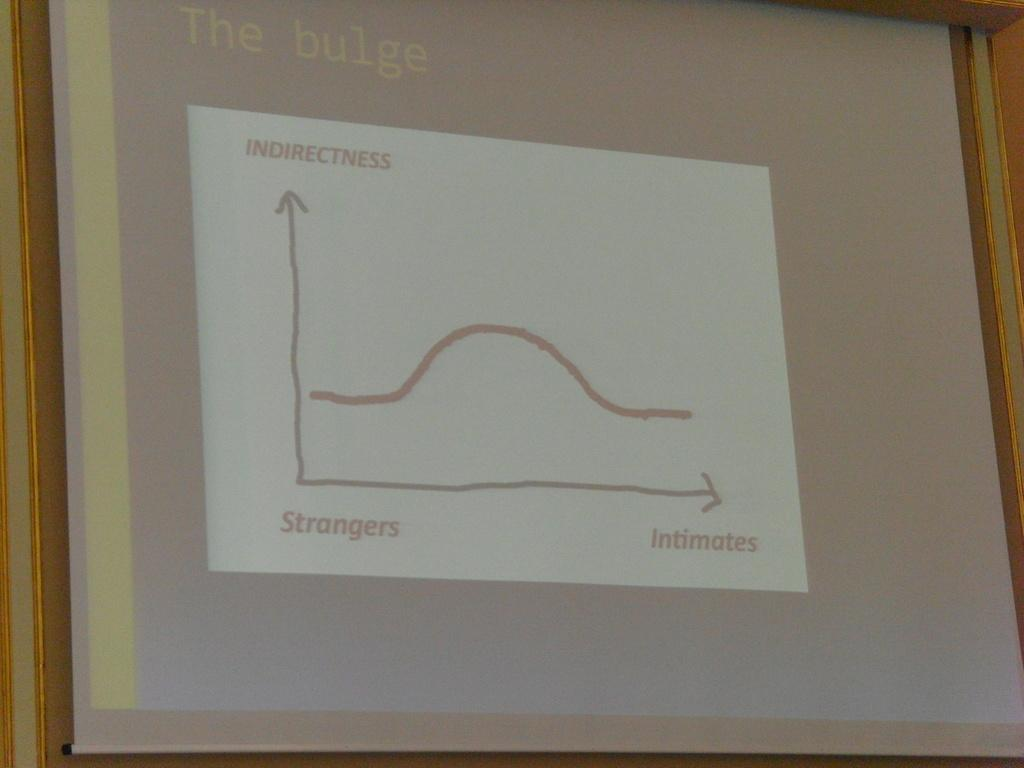Provide a one-sentence caption for the provided image. A projector screen shows a graph of the relationship between indirectness and how well you know someone. 